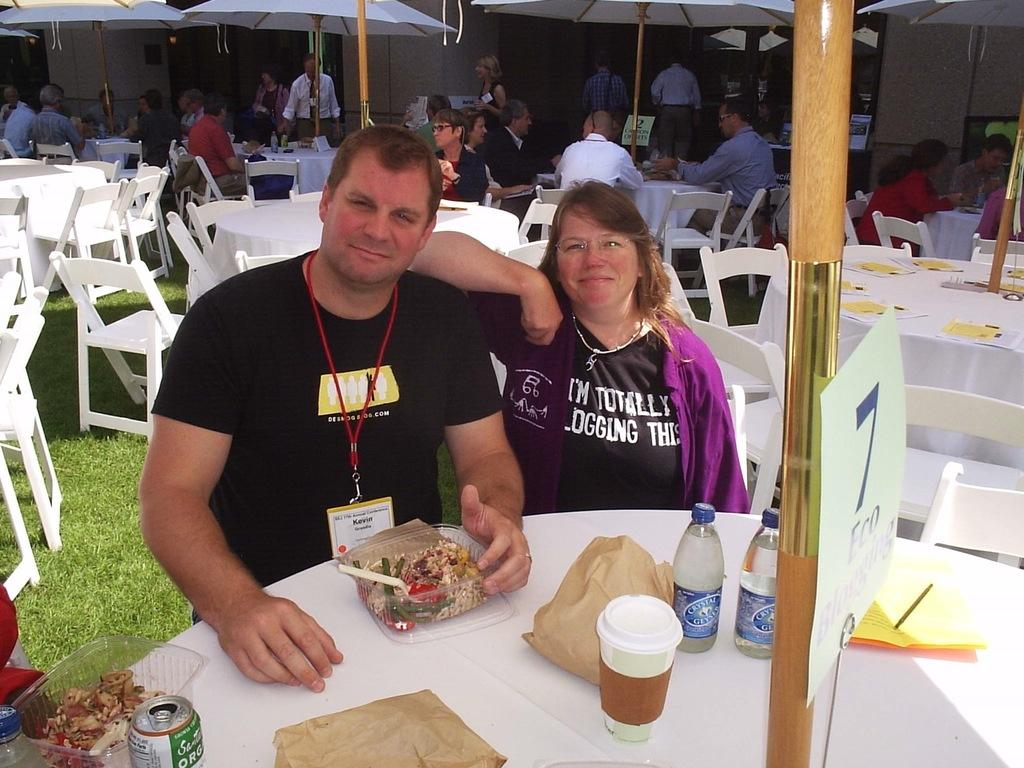How many people are in the image? There are people in the image, but the exact number is not specified. What type of furniture is present in the image? There are chairs and tables in the image. What objects can be seen on the table? There is a box, a tin, a cover, a bottle, and a glass on the table. What is the woman's desire for the minute in the image? There is no woman present in the image, so it is not possible to answer this question. 